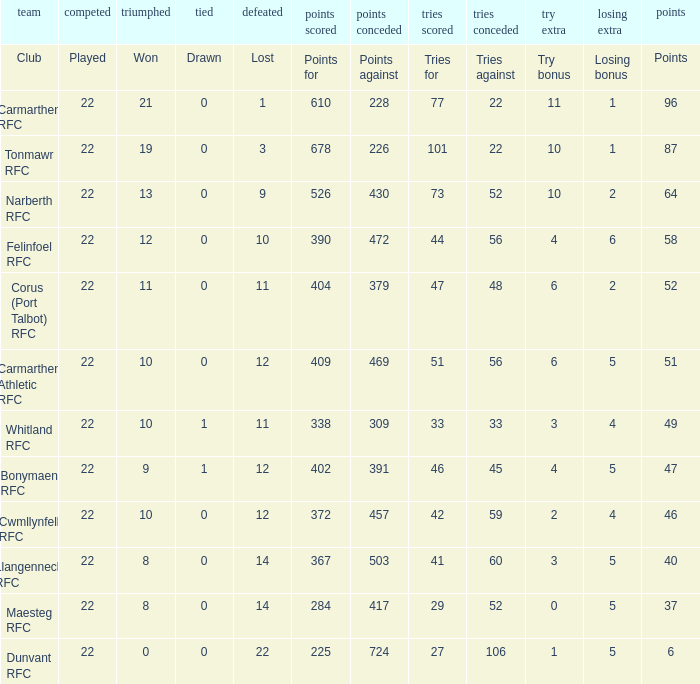Name the losing bonus of 96 points 1.0. 